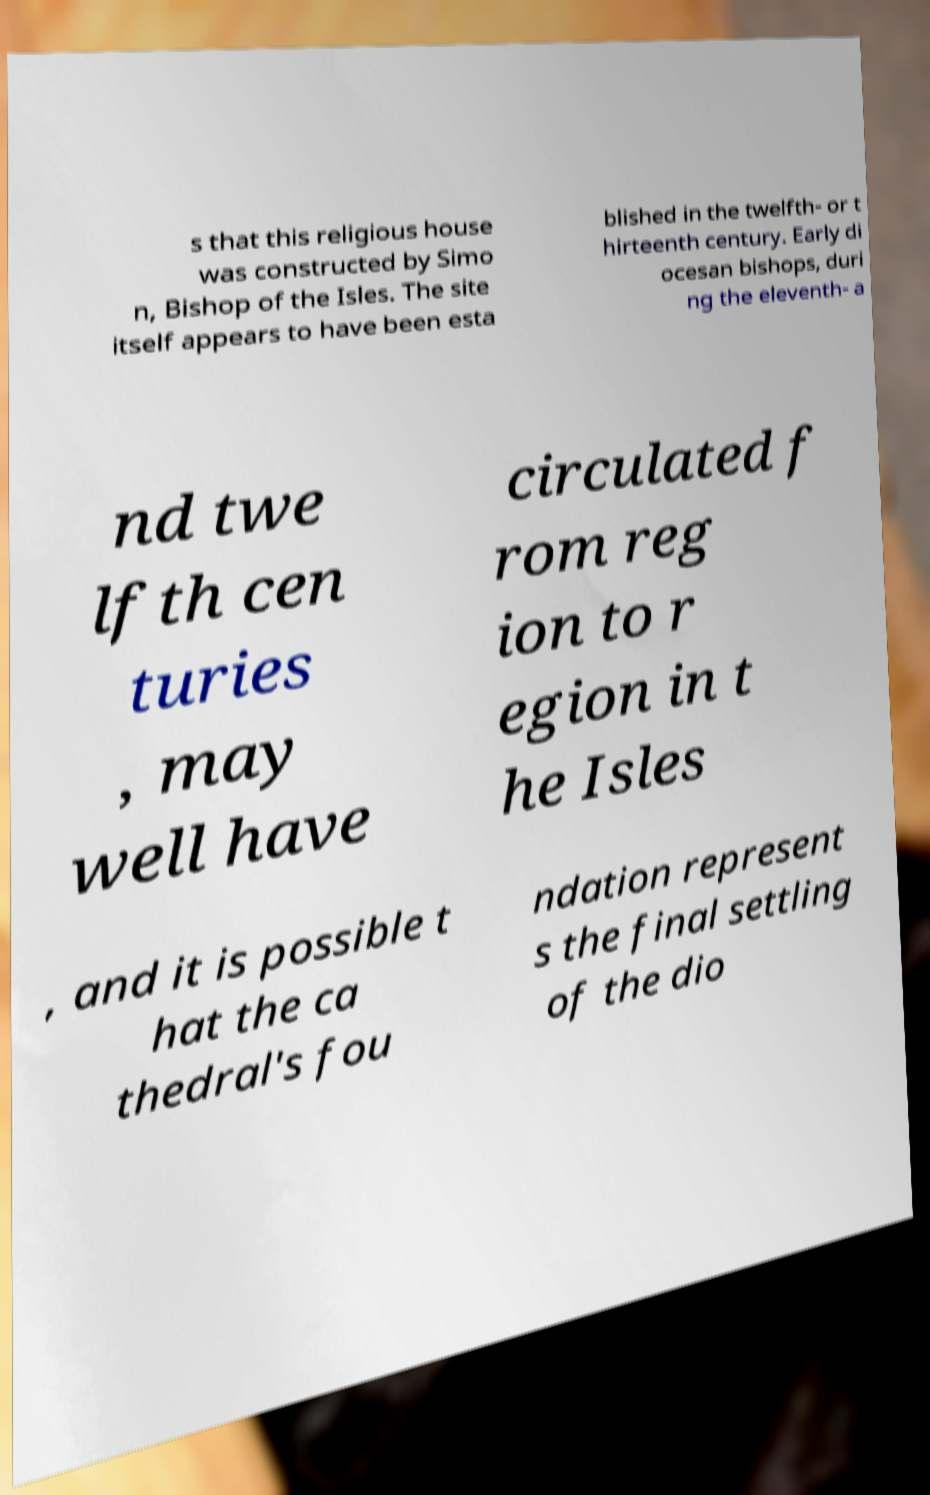I need the written content from this picture converted into text. Can you do that? s that this religious house was constructed by Simo n, Bishop of the Isles. The site itself appears to have been esta blished in the twelfth- or t hirteenth century. Early di ocesan bishops, duri ng the eleventh- a nd twe lfth cen turies , may well have circulated f rom reg ion to r egion in t he Isles , and it is possible t hat the ca thedral's fou ndation represent s the final settling of the dio 